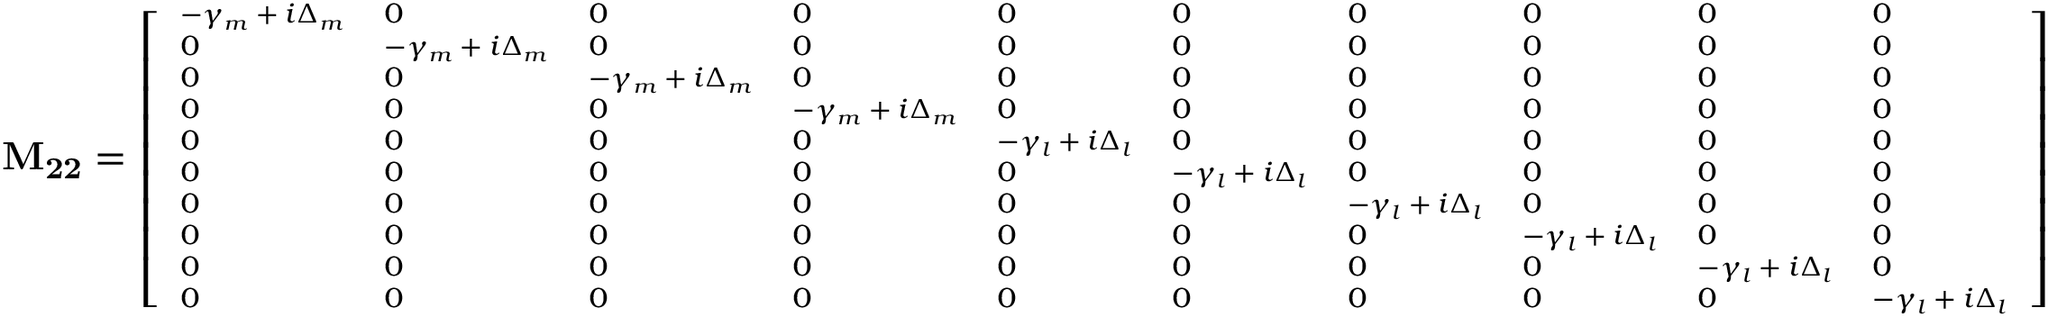Convert formula to latex. <formula><loc_0><loc_0><loc_500><loc_500>M _ { 2 2 } = \left [ \begin{array} { l l l l l l l l l l } { - \gamma _ { m } + i \Delta _ { m } } & { 0 } & { 0 } & { 0 } & { 0 } & { 0 } & { 0 } & { 0 } & { 0 } & { 0 } \\ { 0 } & { - \gamma _ { m } + i \Delta _ { m } } & { 0 } & { 0 } & { 0 } & { 0 } & { 0 } & { 0 } & { 0 } & { 0 } \\ { 0 } & { 0 } & { - \gamma _ { m } + i \Delta _ { m } } & { 0 } & { 0 } & { 0 } & { 0 } & { 0 } & { 0 } & { 0 } \\ { 0 } & { 0 } & { 0 } & { - \gamma _ { m } + i \Delta _ { m } } & { 0 } & { 0 } & { 0 } & { 0 } & { 0 } & { 0 } \\ { 0 } & { 0 } & { 0 } & { 0 } & { - \gamma _ { l } + i \Delta _ { l } } & { 0 } & { 0 } & { 0 } & { 0 } & { 0 } \\ { 0 } & { 0 } & { 0 } & { 0 } & { 0 } & { - \gamma _ { l } + i \Delta _ { l } } & { 0 } & { 0 } & { 0 } & { 0 } \\ { 0 } & { 0 } & { 0 } & { 0 } & { 0 } & { 0 } & { - \gamma _ { l } + i \Delta _ { l } } & { 0 } & { 0 } & { 0 } \\ { 0 } & { 0 } & { 0 } & { 0 } & { 0 } & { 0 } & { 0 } & { - \gamma _ { l } + i \Delta _ { l } } & { 0 } & { 0 } \\ { 0 } & { 0 } & { 0 } & { 0 } & { 0 } & { 0 } & { 0 } & { 0 } & { - \gamma _ { l } + i \Delta _ { l } } & { 0 } \\ { 0 } & { 0 } & { 0 } & { 0 } & { 0 } & { 0 } & { 0 } & { 0 } & { 0 } & { - \gamma _ { l } + i \Delta _ { l } } \end{array} \right ]</formula> 